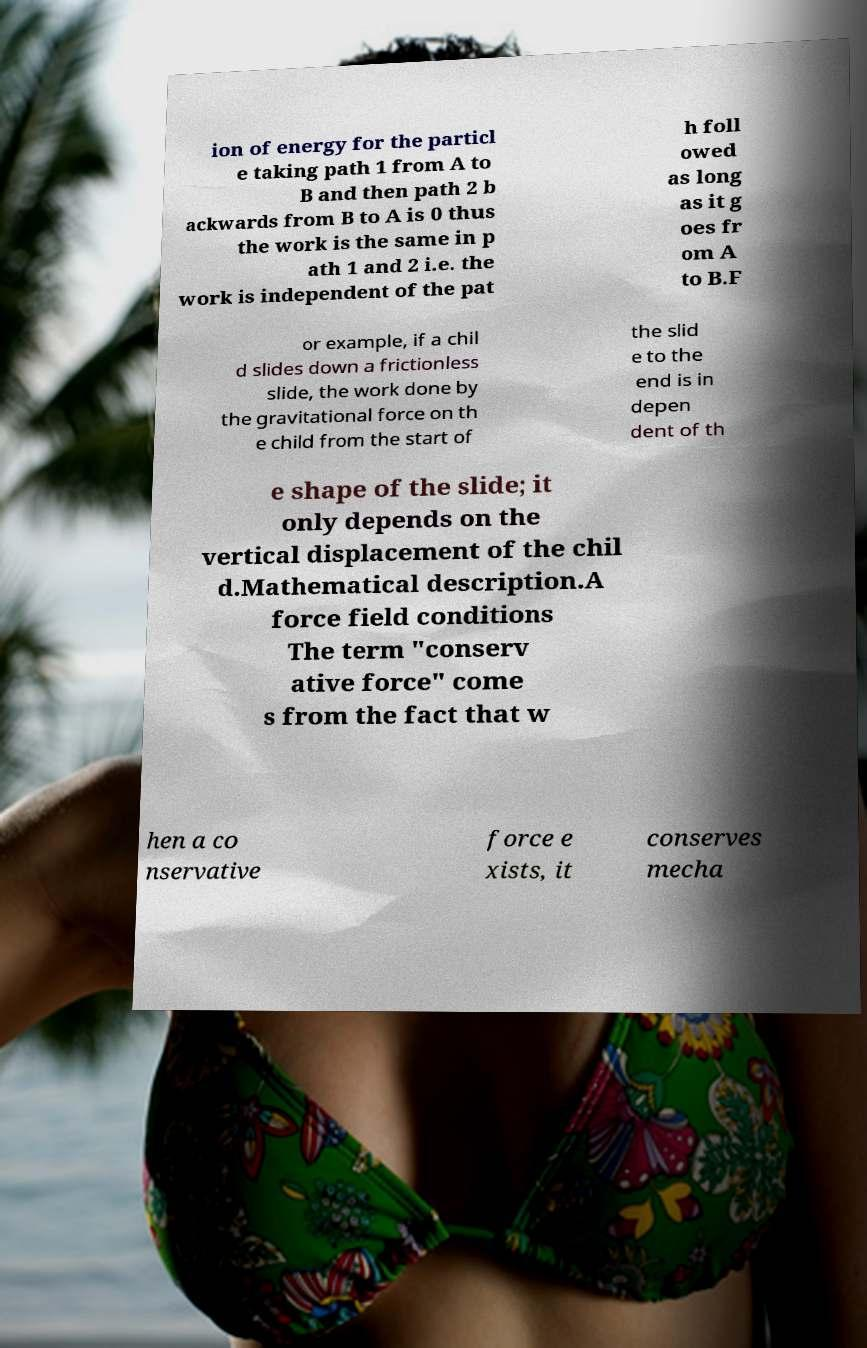Please read and relay the text visible in this image. What does it say? ion of energy for the particl e taking path 1 from A to B and then path 2 b ackwards from B to A is 0 thus the work is the same in p ath 1 and 2 i.e. the work is independent of the pat h foll owed as long as it g oes fr om A to B.F or example, if a chil d slides down a frictionless slide, the work done by the gravitational force on th e child from the start of the slid e to the end is in depen dent of th e shape of the slide; it only depends on the vertical displacement of the chil d.Mathematical description.A force field conditions The term "conserv ative force" come s from the fact that w hen a co nservative force e xists, it conserves mecha 